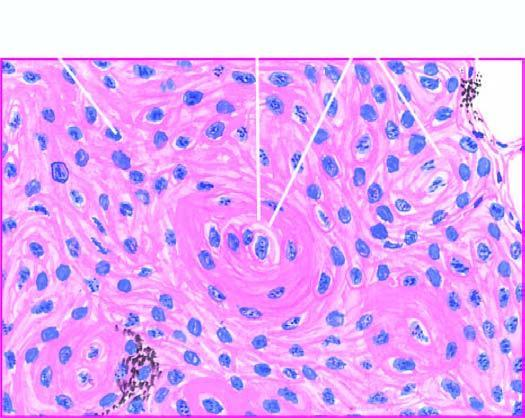re a few well-developed cell nests with keratinisation evident?
Answer the question using a single word or phrase. Yes 